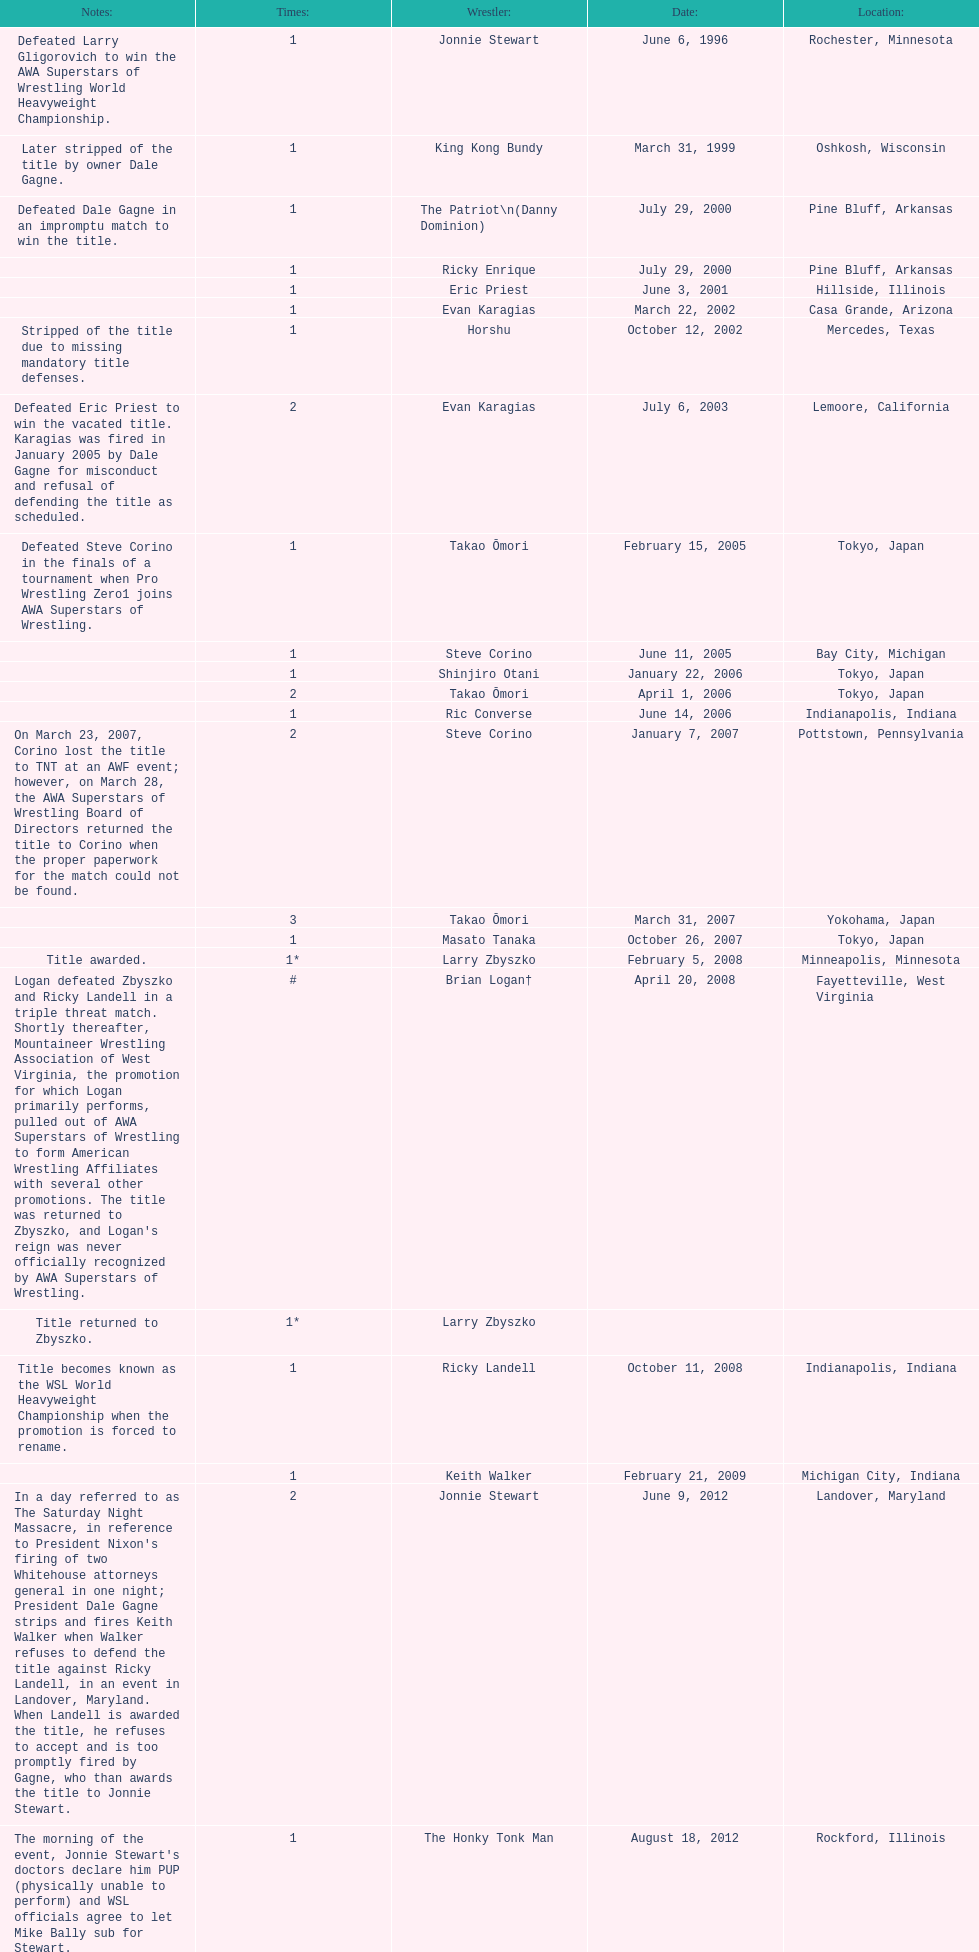Where are the title holders from? Rochester, Minnesota, Oshkosh, Wisconsin, Pine Bluff, Arkansas, Pine Bluff, Arkansas, Hillside, Illinois, Casa Grande, Arizona, Mercedes, Texas, Lemoore, California, Tokyo, Japan, Bay City, Michigan, Tokyo, Japan, Tokyo, Japan, Indianapolis, Indiana, Pottstown, Pennsylvania, Yokohama, Japan, Tokyo, Japan, Minneapolis, Minnesota, Fayetteville, West Virginia, , Indianapolis, Indiana, Michigan City, Indiana, Landover, Maryland, Rockford, Illinois. Who is the title holder from texas? Horshu. 